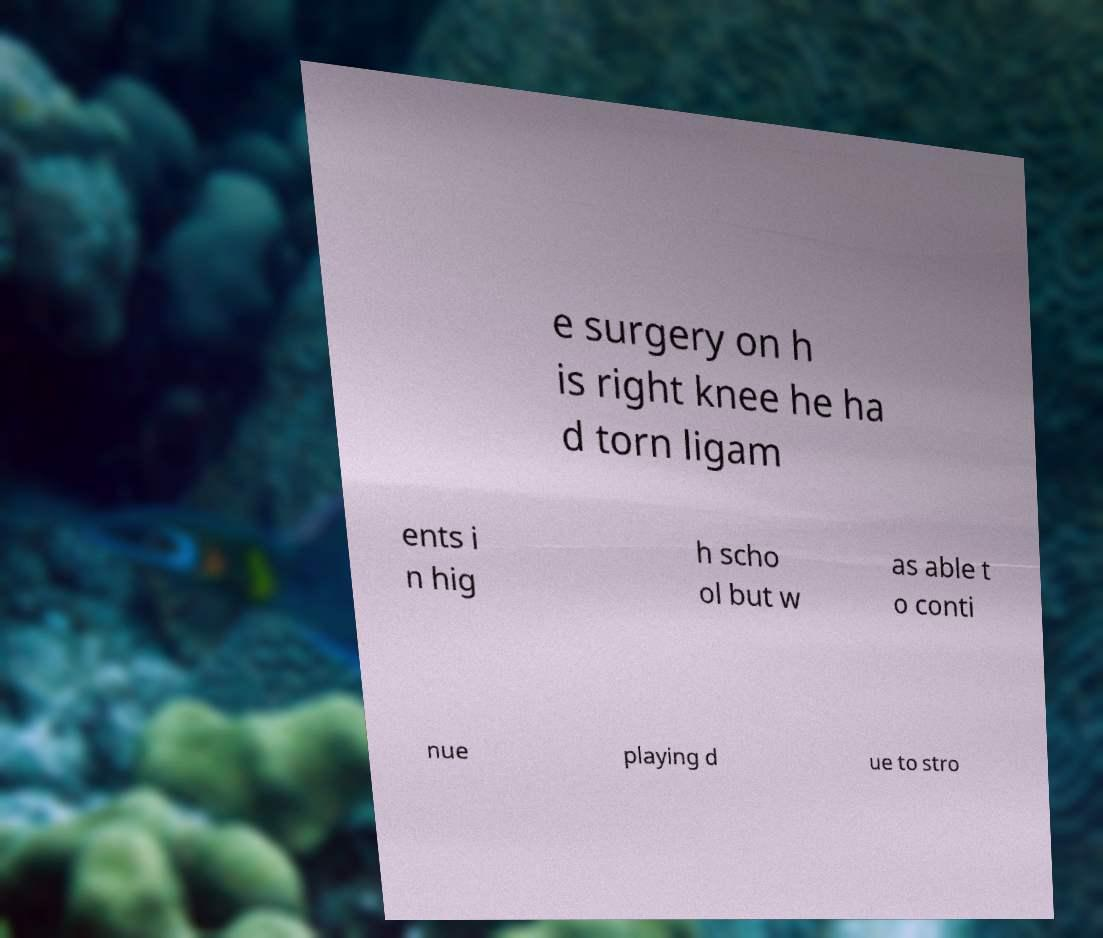Can you accurately transcribe the text from the provided image for me? e surgery on h is right knee he ha d torn ligam ents i n hig h scho ol but w as able t o conti nue playing d ue to stro 